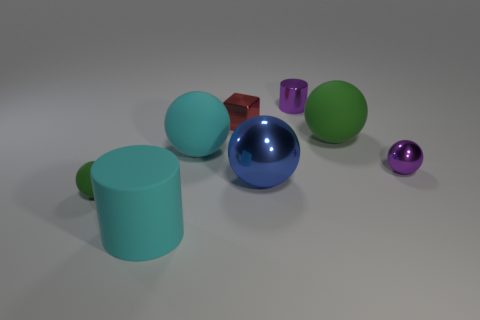Subtract all purple metallic balls. How many balls are left? 4 Subtract all cyan spheres. How many spheres are left? 4 Subtract all gray spheres. Subtract all cyan cubes. How many spheres are left? 5 Add 1 small shiny cylinders. How many objects exist? 9 Subtract all cylinders. How many objects are left? 6 Subtract all big blue things. Subtract all large metallic things. How many objects are left? 6 Add 4 red things. How many red things are left? 5 Add 3 tiny red metallic cubes. How many tiny red metallic cubes exist? 4 Subtract 0 green cylinders. How many objects are left? 8 